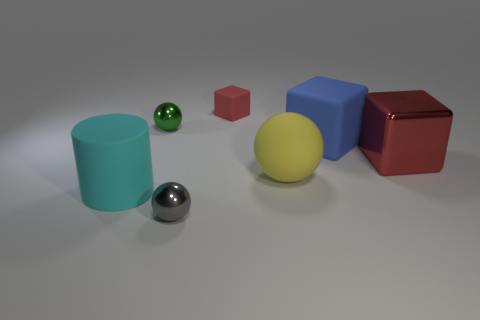What size is the thing that is the same color as the large metallic block?
Make the answer very short. Small. There is a yellow thing that is the same shape as the tiny green object; what is it made of?
Your answer should be very brief. Rubber. Is the number of metal things left of the small rubber block greater than the number of big rubber cylinders?
Provide a short and direct response. Yes. Are there any other things that are the same color as the big rubber cube?
Make the answer very short. No. There is a yellow object that is made of the same material as the cylinder; what is its shape?
Give a very brief answer. Sphere. Does the tiny object in front of the large cyan matte object have the same material as the cylinder?
Offer a terse response. No. Does the matte object left of the tiny matte object have the same color as the tiny metallic object that is behind the blue block?
Make the answer very short. No. How many shiny objects are behind the large matte cylinder and in front of the big yellow matte thing?
Your response must be concise. 0. What is the material of the tiny red thing?
Your answer should be very brief. Rubber. There is a yellow matte object that is the same size as the blue rubber thing; what shape is it?
Keep it short and to the point. Sphere. 